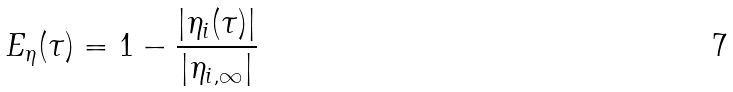<formula> <loc_0><loc_0><loc_500><loc_500>E _ { \eta } ( \tau ) = 1 - \frac { | \eta _ { i } ( \tau ) | } { | \eta _ { i , \infty } | }</formula> 